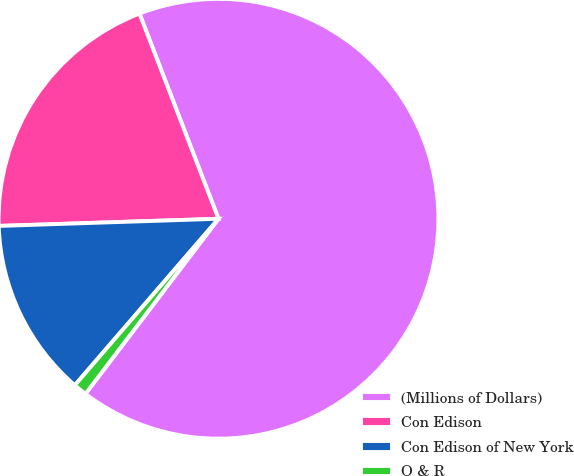<chart> <loc_0><loc_0><loc_500><loc_500><pie_chart><fcel>(Millions of Dollars)<fcel>Con Edison<fcel>Con Edison of New York<fcel>O & R<nl><fcel>66.2%<fcel>19.67%<fcel>13.15%<fcel>0.99%<nl></chart> 